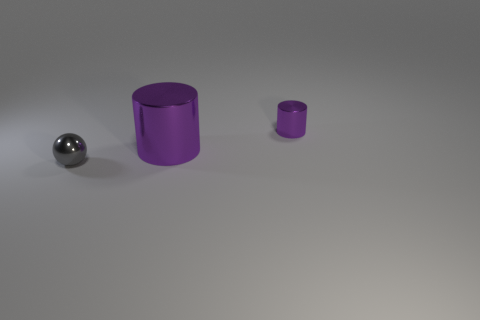Can you describe the lighting in this scene? The lighting in the scene is diffuse, with soft shadows indicating an overhead light source that is not too harsh. This creates a gentle illumination on the objects without casting strong, distinct shadows.  Does the lighting affect the color of the objects? Given that the light is diffuse, it does not appear to significantly alter the objects' colors. The metallic and purple finishes maintain their inherent color properties under this lighting condition. 